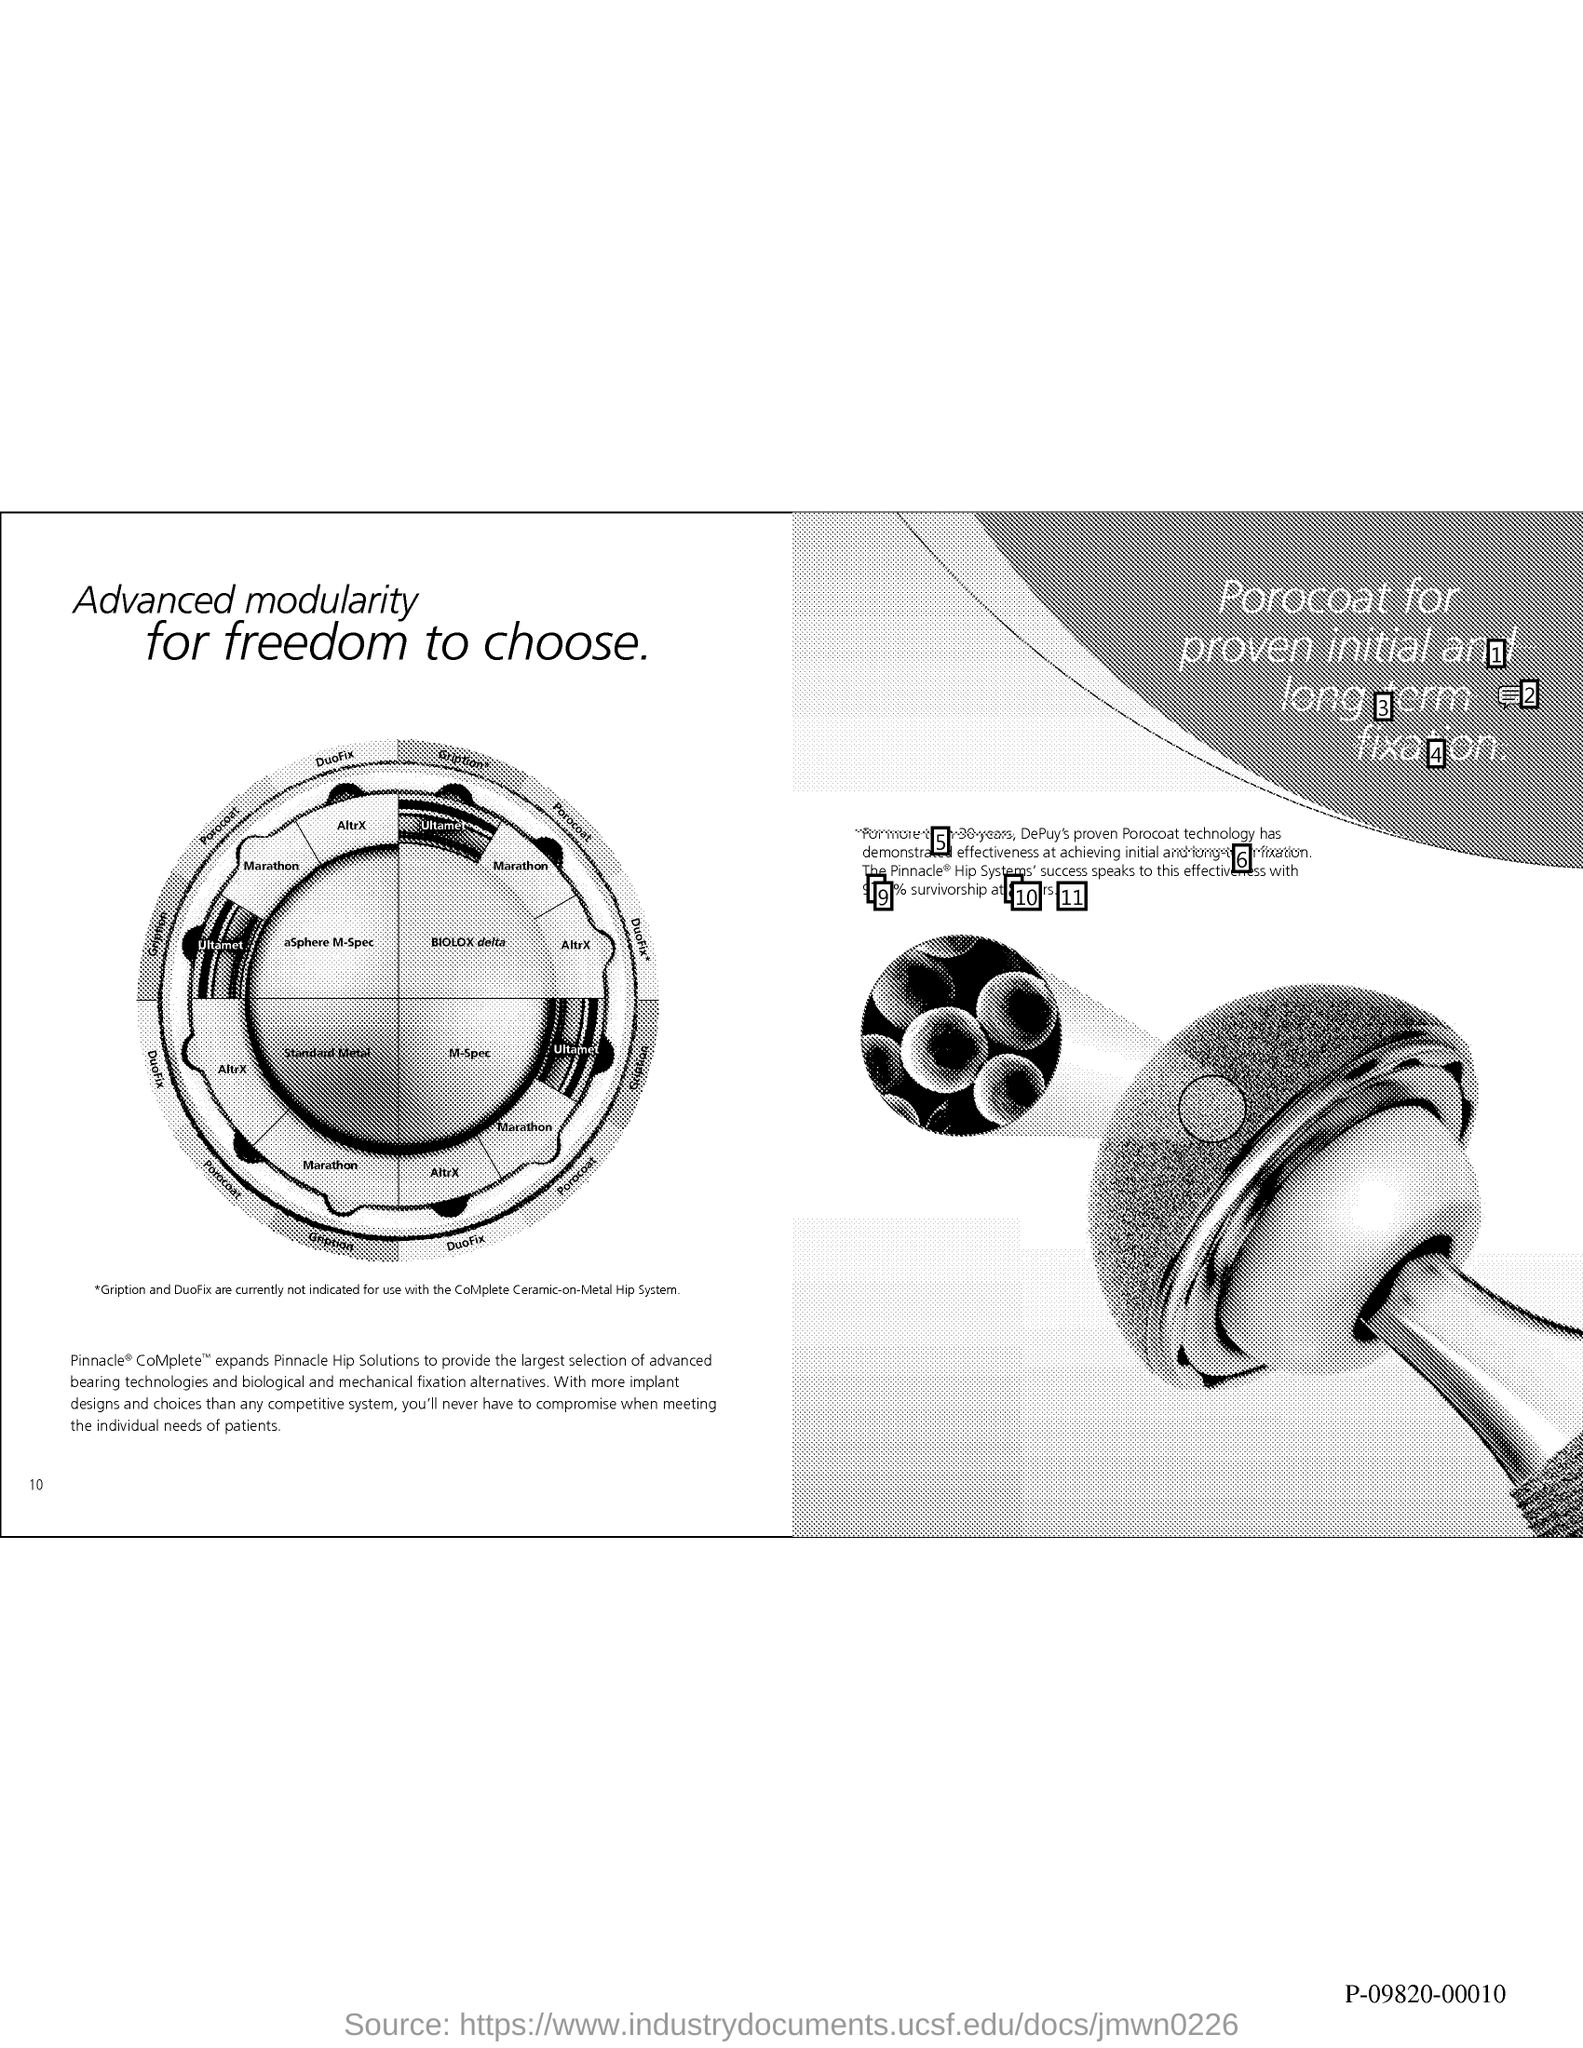What is the Page Number?
Provide a succinct answer. 10. 